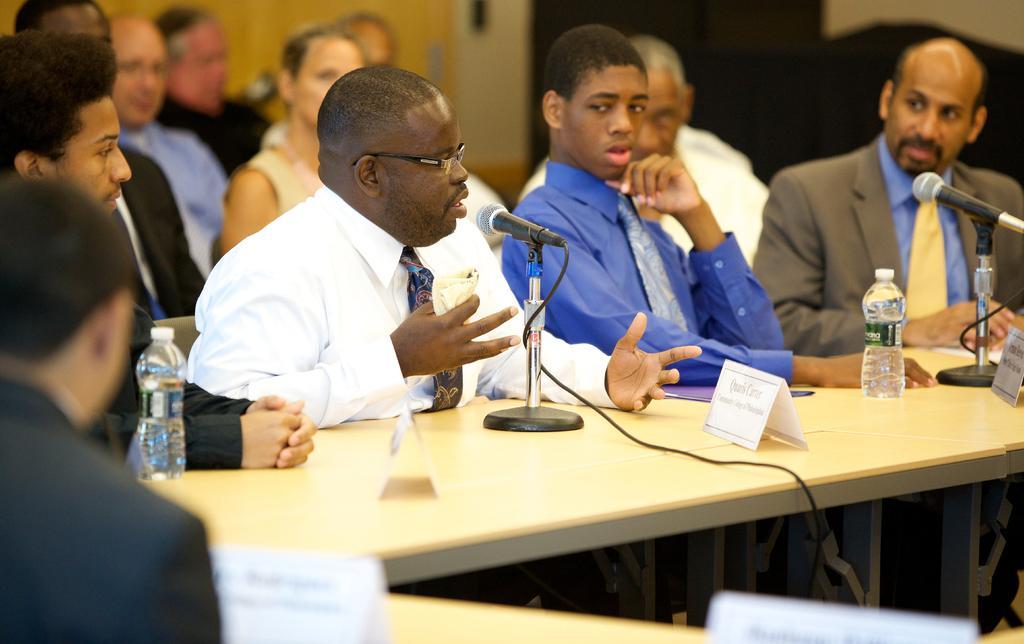Please provide a concise description of this image. In this image we can see persons sitting on the chairs and tables are placed in front of them. On the tables there are name plates, disposable bottles, mics and electric cables. 